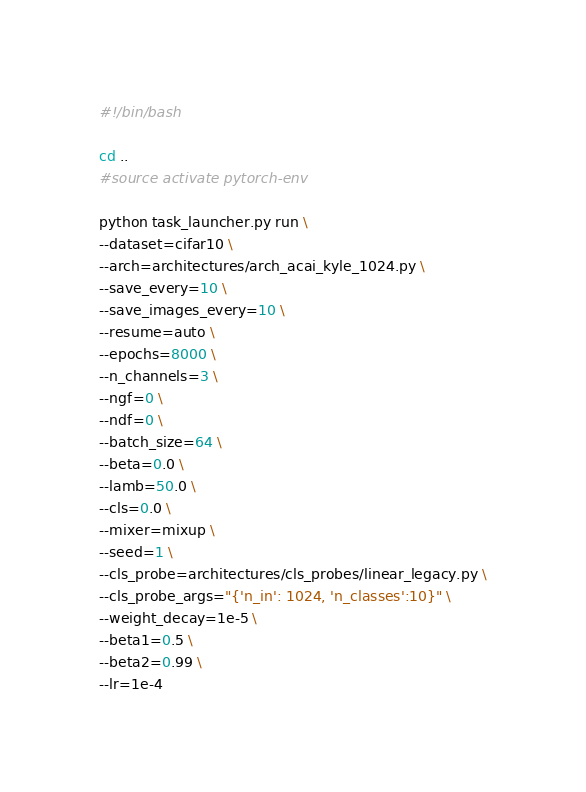Convert code to text. <code><loc_0><loc_0><loc_500><loc_500><_Bash_>#!/bin/bash

cd ..
#source activate pytorch-env

python task_launcher.py run \
--dataset=cifar10 \
--arch=architectures/arch_acai_kyle_1024.py \
--save_every=10 \
--save_images_every=10 \
--resume=auto \
--epochs=8000 \
--n_channels=3 \
--ngf=0 \
--ndf=0 \
--batch_size=64 \
--beta=0.0 \
--lamb=50.0 \
--cls=0.0 \
--mixer=mixup \
--seed=1 \
--cls_probe=architectures/cls_probes/linear_legacy.py \
--cls_probe_args="{'n_in': 1024, 'n_classes':10}" \
--weight_decay=1e-5 \
--beta1=0.5 \
--beta2=0.99 \
--lr=1e-4
</code> 